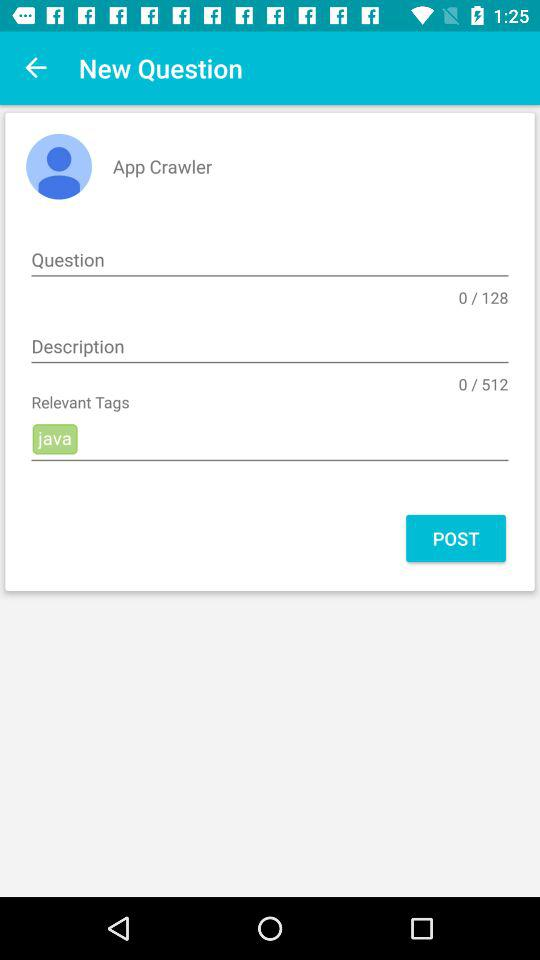In how many words can you write the description? You can write the description in 512 words. 